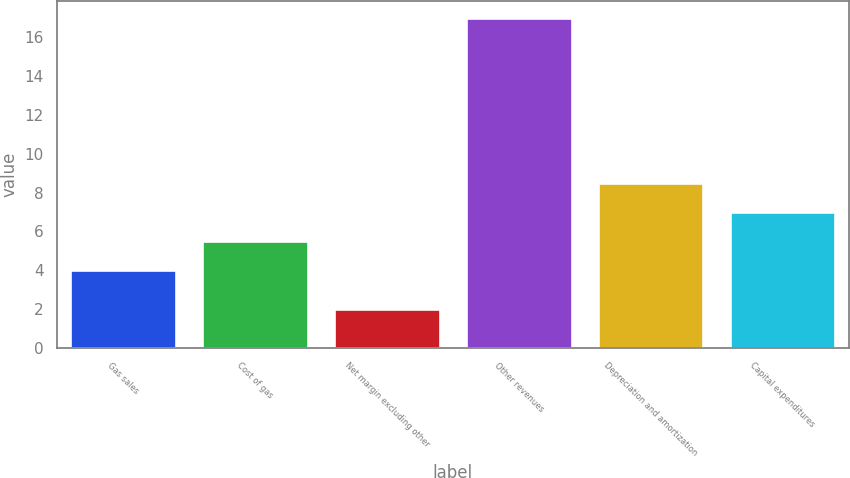Convert chart to OTSL. <chart><loc_0><loc_0><loc_500><loc_500><bar_chart><fcel>Gas sales<fcel>Cost of gas<fcel>Net margin excluding other<fcel>Other revenues<fcel>Depreciation and amortization<fcel>Capital expenditures<nl><fcel>4<fcel>5.5<fcel>2<fcel>17<fcel>8.5<fcel>7<nl></chart> 